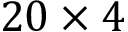Convert formula to latex. <formula><loc_0><loc_0><loc_500><loc_500>2 0 \times 4</formula> 